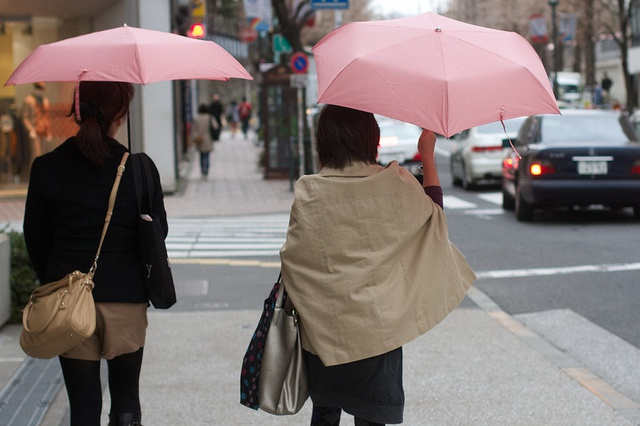Describe the objects in this image and their specific colors. I can see people in brown, gray, and black tones, people in brown, black, maroon, and gray tones, umbrella in brown, lightpink, pink, and salmon tones, car in brown, black, lightgray, and gray tones, and umbrella in brown, lightpink, pink, and gray tones in this image. 